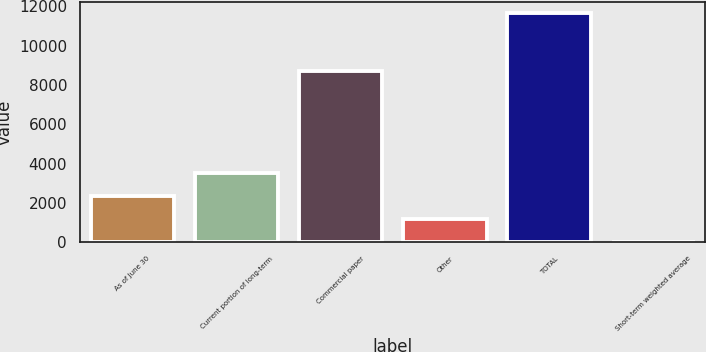Convert chart to OTSL. <chart><loc_0><loc_0><loc_500><loc_500><bar_chart><fcel>As of June 30<fcel>Current portion of long-term<fcel>Commercial paper<fcel>Other<fcel>TOTAL<fcel>Short-term weighted average<nl><fcel>2330.76<fcel>3496.04<fcel>8690<fcel>1165.48<fcel>11653<fcel>0.2<nl></chart> 